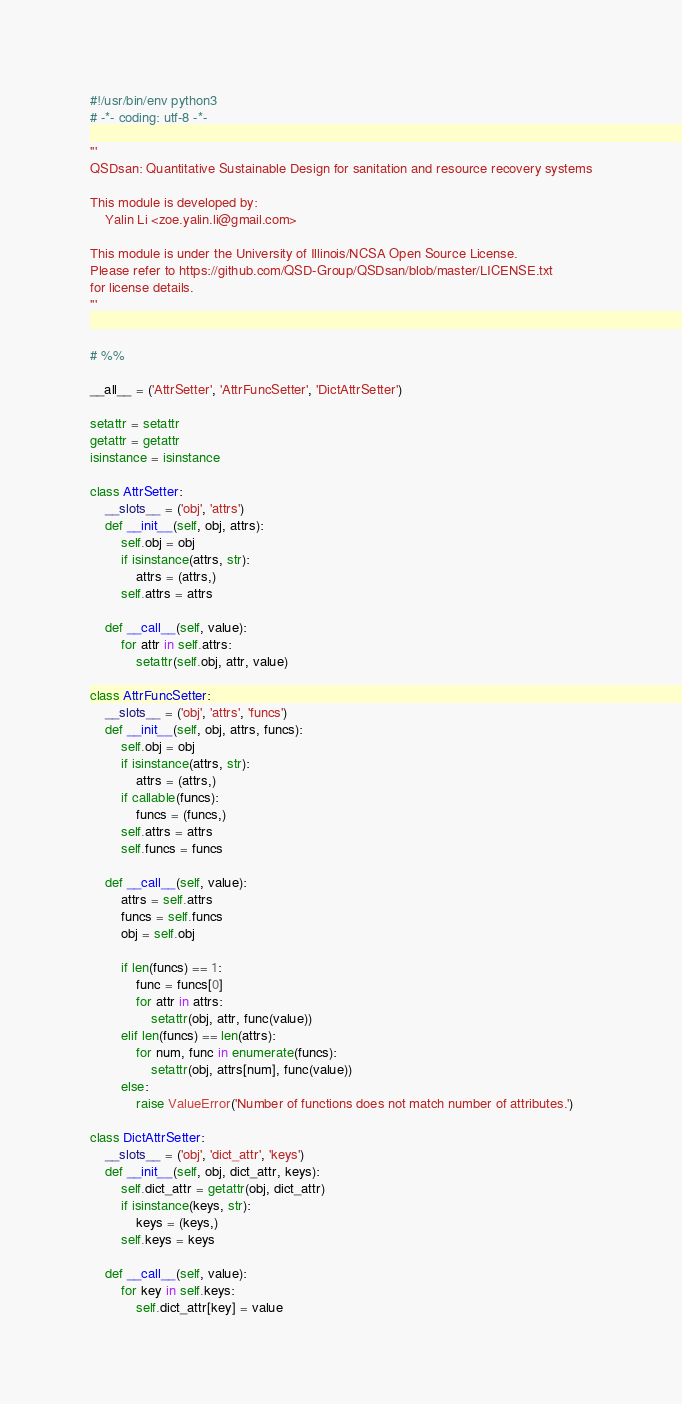Convert code to text. <code><loc_0><loc_0><loc_500><loc_500><_Python_>#!/usr/bin/env python3
# -*- coding: utf-8 -*-

'''
QSDsan: Quantitative Sustainable Design for sanitation and resource recovery systems

This module is developed by:
    Yalin Li <zoe.yalin.li@gmail.com>

This module is under the University of Illinois/NCSA Open Source License.
Please refer to https://github.com/QSD-Group/QSDsan/blob/master/LICENSE.txt
for license details.
'''


# %%

__all__ = ('AttrSetter', 'AttrFuncSetter', 'DictAttrSetter')

setattr = setattr
getattr = getattr
isinstance = isinstance

class AttrSetter:
    __slots__ = ('obj', 'attrs')
    def __init__(self, obj, attrs):
        self.obj = obj
        if isinstance(attrs, str):
            attrs = (attrs,)
        self.attrs = attrs
        
    def __call__(self, value):
        for attr in self.attrs:
            setattr(self.obj, attr, value)

class AttrFuncSetter:
    __slots__ = ('obj', 'attrs', 'funcs')
    def __init__(self, obj, attrs, funcs):
        self.obj = obj
        if isinstance(attrs, str):
            attrs = (attrs,)
        if callable(funcs):
            funcs = (funcs,)
        self.attrs = attrs
        self.funcs = funcs
        
    def __call__(self, value):
        attrs = self.attrs
        funcs = self.funcs
        obj = self.obj
        
        if len(funcs) == 1:
            func = funcs[0]
            for attr in attrs:
                setattr(obj, attr, func(value))
        elif len(funcs) == len(attrs):
            for num, func in enumerate(funcs):
                setattr(obj, attrs[num], func(value))
        else:
            raise ValueError('Number of functions does not match number of attributes.')

class DictAttrSetter:
    __slots__ = ('obj', 'dict_attr', 'keys')
    def __init__(self, obj, dict_attr, keys):
        self.dict_attr = getattr(obj, dict_attr)
        if isinstance(keys, str):
            keys = (keys,)
        self.keys = keys

    def __call__(self, value):
        for key in self.keys:
            self.dict_attr[key] = value

</code> 